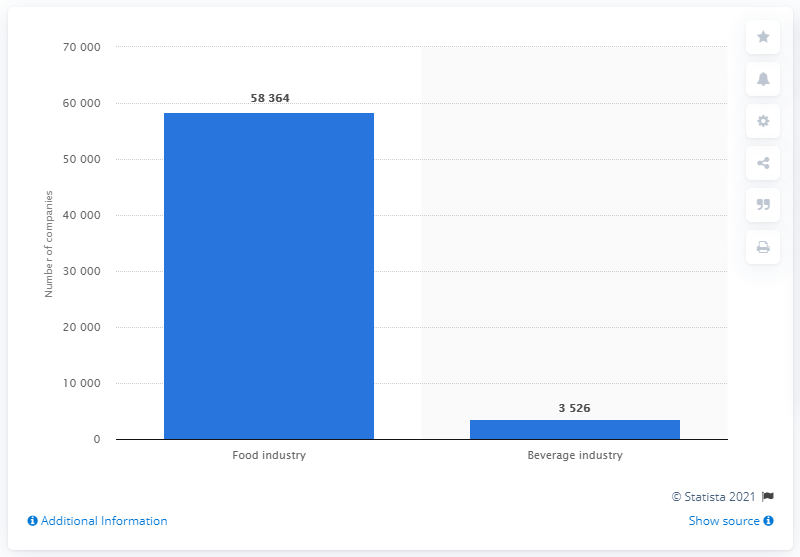How many companies were in the food and beverage industry in Italy in the second quarter of 2017?
 58364 